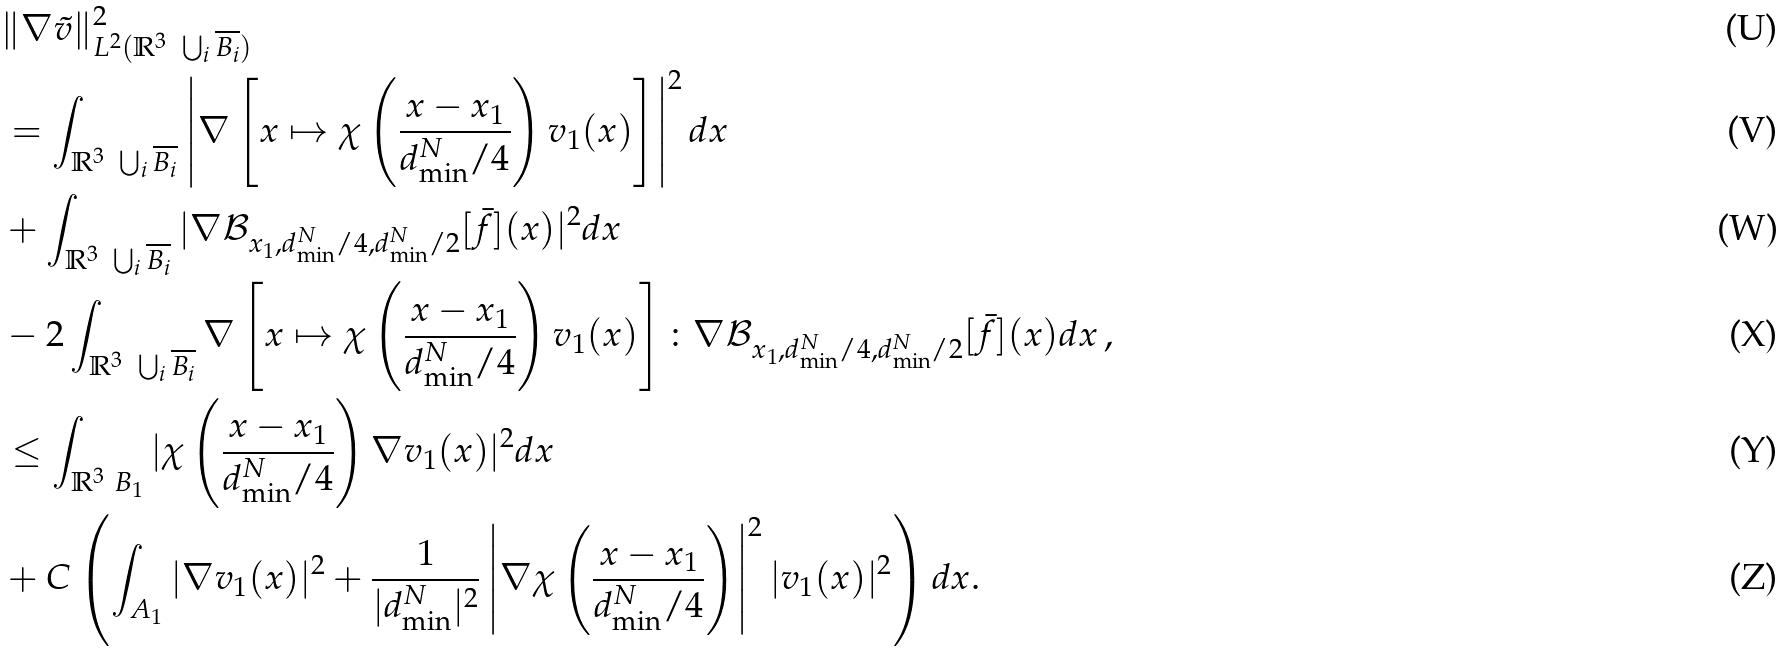<formula> <loc_0><loc_0><loc_500><loc_500>& \| \nabla \tilde { v } \| ^ { 2 } _ { L ^ { 2 } ( \mathbb { R } ^ { 3 } \ \bigcup _ { i } \overline { B _ { i } } ) } \\ & = \int _ { \mathbb { R } ^ { 3 } \ \bigcup _ { i } \overline { B _ { i } } } \left | \nabla \left [ x \mapsto \chi \left ( \frac { x - x _ { 1 } } { d _ { \min } ^ { N } / 4 } \right ) v _ { 1 } ( x ) \right ] \right | ^ { 2 } d x \\ & + \int _ { \mathbb { R } ^ { 3 } \ \bigcup _ { i } \overline { B _ { i } } } | \nabla \mathcal { B } _ { x _ { 1 } , d _ { \min } ^ { N } / 4 , d _ { \min } ^ { N } / 2 } [ \bar { f } ] ( x ) | ^ { 2 } d x \\ & - 2 \int _ { \mathbb { R } ^ { 3 } \ \bigcup _ { i } \overline { B _ { i } } } \nabla \left [ x \mapsto \chi \left ( \frac { x - x _ { 1 } } { d _ { \min } ^ { N } / 4 } \right ) v _ { 1 } ( x ) \right ] \colon \nabla \mathcal { B } _ { x _ { 1 } , d _ { \min } ^ { N } / 4 , d _ { \min } ^ { N } / 2 } [ \bar { f } ] ( x ) d x \, , \\ & \leq \int _ { \mathbb { R } ^ { 3 } \ B _ { 1 } } | \chi \left ( \frac { x - x _ { 1 } } { d _ { \min } ^ { N } / 4 } \right ) \nabla v _ { 1 } ( x ) | ^ { 2 } d x \\ & + C \left ( \int _ { A _ { 1 } } | \nabla v _ { 1 } ( x ) | ^ { 2 } + \frac { 1 } { | d _ { \min } ^ { N } | ^ { 2 } } \left | \nabla \chi \left ( \frac { x - x _ { 1 } } { d _ { \min } ^ { N } / 4 } \right ) \right | ^ { 2 } | v _ { 1 } ( x ) | ^ { 2 } \right ) d x .</formula> 